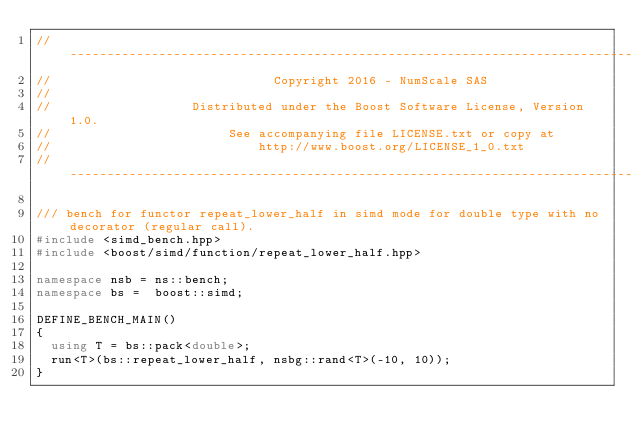<code> <loc_0><loc_0><loc_500><loc_500><_C++_>// -------------------------------------------------------------------------------------------------
//                              Copyright 2016 - NumScale SAS
//
//                   Distributed under the Boost Software License, Version 1.0.
//                        See accompanying file LICENSE.txt or copy at
//                            http://www.boost.org/LICENSE_1_0.txt
// -------------------------------------------------------------------------------------------------

/// bench for functor repeat_lower_half in simd mode for double type with no decorator (regular call).
#include <simd_bench.hpp>
#include <boost/simd/function/repeat_lower_half.hpp>

namespace nsb = ns::bench;
namespace bs =  boost::simd;

DEFINE_BENCH_MAIN()
{
  using T = bs::pack<double>;
  run<T>(bs::repeat_lower_half, nsbg::rand<T>(-10, 10));
}
</code> 